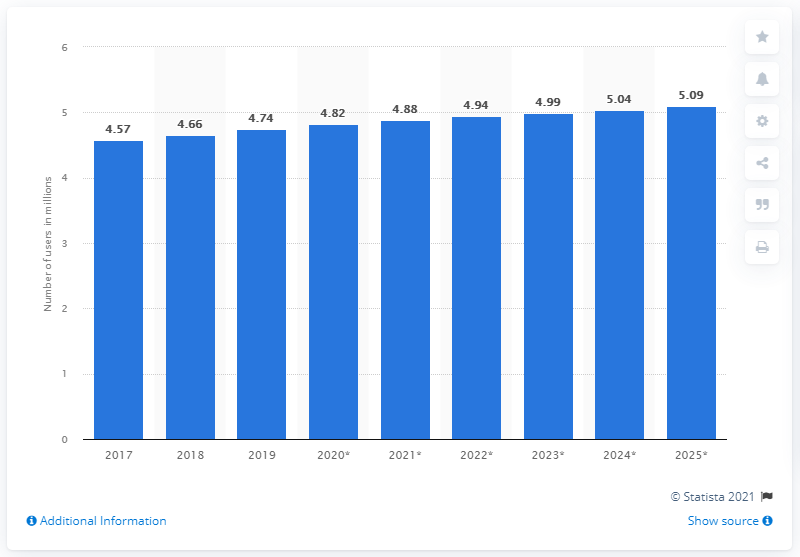Indicate a few pertinent items in this graphic. In 2019, there were 4.74 million social network users in Singapore. 